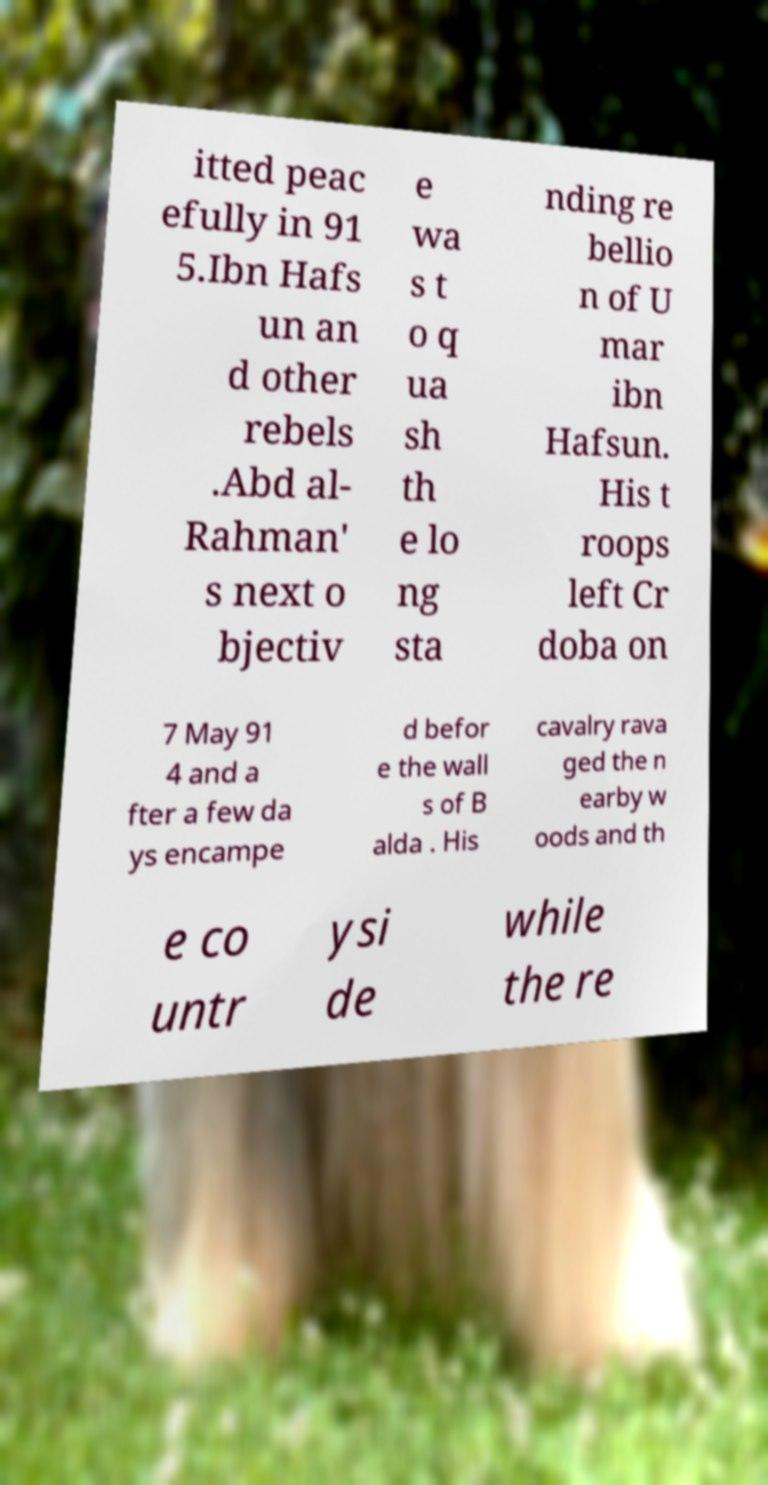What messages or text are displayed in this image? I need them in a readable, typed format. itted peac efully in 91 5.Ibn Hafs un an d other rebels .Abd al- Rahman' s next o bjectiv e wa s t o q ua sh th e lo ng sta nding re bellio n of U mar ibn Hafsun. His t roops left Cr doba on 7 May 91 4 and a fter a few da ys encampe d befor e the wall s of B alda . His cavalry rava ged the n earby w oods and th e co untr ysi de while the re 